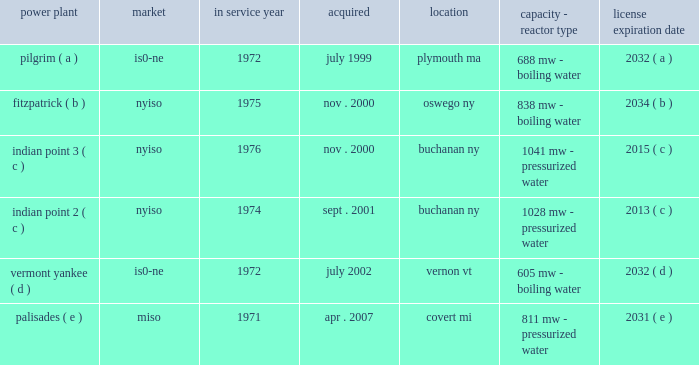Part i item 1 entergy corporation , utility operating companies , and system energy including the continued effectiveness of the clean energy standards/zero emissions credit program ( ces/zec ) , the establishment of certain long-term agreements on acceptable terms with the energy research and development authority of the state of new york in connection with the ces/zec program , and nypsc approval of the transaction on acceptable terms , entergy refueled the fitzpatrick plant in january and february 2017 .
In october 2015 , entergy determined that it would close the pilgrim plant .
The decision came after management 2019s extensive analysis of the economics and operating life of the plant following the nrc 2019s decision in september 2015 to place the plant in its 201cmultiple/repetitive degraded cornerstone column 201d ( column 4 ) of its reactor oversight process action matrix .
The pilgrim plant is expected to cease operations on may 31 , 2019 , after refueling in the spring of 2017 and operating through the end of that fuel cycle .
In december 2015 , entergy wholesale commodities closed on the sale of its 583 mw rhode island state energy center ( risec ) , in johnston , rhode island .
The base sales price , excluding adjustments , was approximately $ 490 million .
Entergy wholesale commodities purchased risec for $ 346 million in december 2011 .
In december 2016 , entergy announced that it reached an agreement with consumers energy to terminate the ppa for the palisades plant on may 31 , 2018 .
Pursuant to the ppa termination agreement , consumers energy will pay entergy $ 172 million for the early termination of the ppa .
The ppa termination agreement is subject to regulatory approvals .
Separately , and assuming regulatory approvals are obtained for the ppa termination agreement , entergy intends to shut down the palisades nuclear power plant permanently on october 1 , 2018 , after refueling in the spring of 2017 and operating through the end of that fuel cycle .
Entergy expects to enter into a new ppa with consumers energy under which the plant would continue to operate through october 1 , 2018 .
In january 2017 , entergy announced that it reached a settlement with new york state to shut down indian point 2 by april 30 , 2020 and indian point 3 by april 30 , 2021 , and resolve all new york state-initiated legal challenges to indian point 2019s operating license renewal .
As part of the settlement , new york state has agreed to issue indian point 2019s water quality certification and coastal zone management act consistency certification and to withdraw its objection to license renewal before the nrc .
New york state also has agreed to issue a water discharge permit , which is required regardless of whether the plant is seeking a renewed nrc license .
The shutdowns are conditioned , among other things , upon such actions being taken by new york state .
Even without opposition , the nrc license renewal process is expected to continue at least into 2018 .
With the settlement concerning indian point , entergy now has announced plans for the disposition of all of the entergy wholesale commodities nuclear power plants , including the sales of vermont yankee and fitzpatrick , and the earlier than previously expected shutdowns of pilgrim , palisades , indian point 2 , and indian point 3 .
See 201centergy wholesale commodities exit from the merchant power business 201d for further discussion .
Property nuclear generating stations entergy wholesale commodities includes the ownership of the following nuclear power plants : power plant market service year acquired location capacity - reactor type license expiration .

What is the total mw capacity of the boiling water reactors? 
Computations: ((688 + 838) + 605)
Answer: 2131.0. 